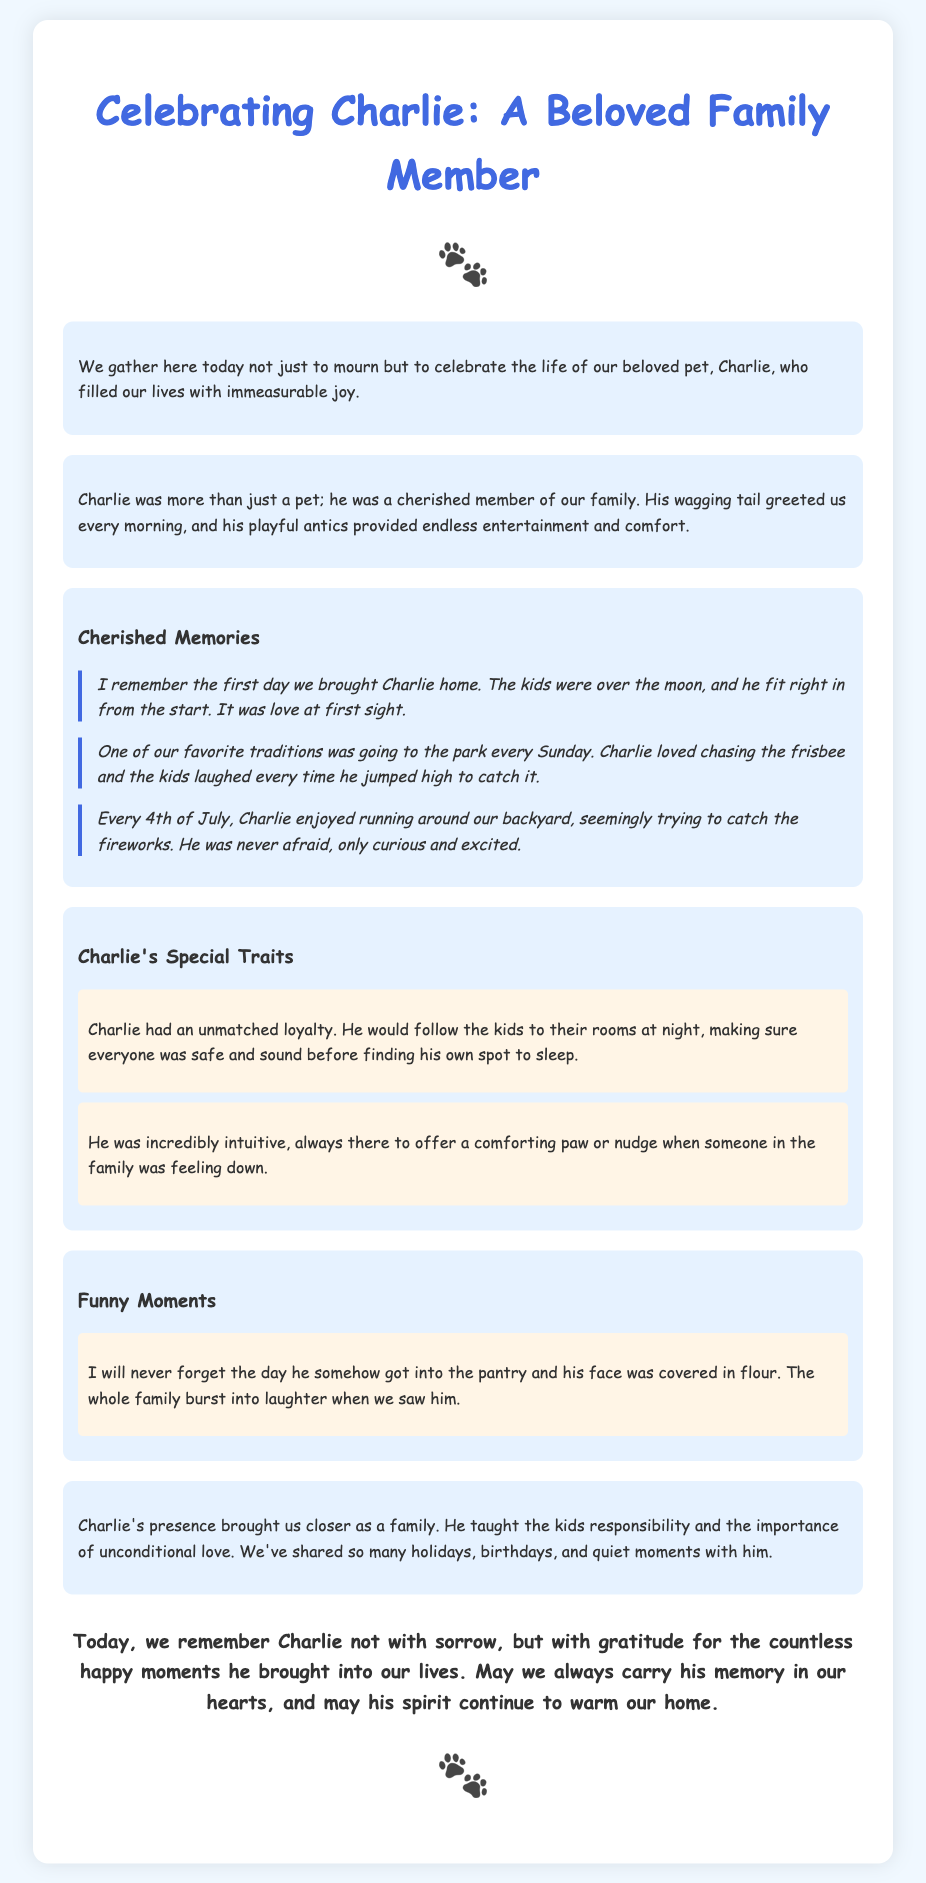What is the name of the pet being celebrated? The name of the pet mentioned in the eulogy is Charlie.
Answer: Charlie What was the family’s favorite tradition with Charlie? The favorite tradition was going to the park every Sunday, where Charlie loved to chase the frisbee.
Answer: Going to the park every Sunday What did Charlie do every 4th of July? Charlie enjoyed running around the backyard, seemingly trying to catch the fireworks.
Answer: Running around the backyard What was Charlie's unmatched trait? Charlie had unmatched loyalty, following the kids at night to ensure their safety.
Answer: Loyalty What was a funny moment shared in the eulogy? A funny moment mentioned was when Charlie got into the pantry and had flour on his face.
Answer: Face covered in flour How did Charlie's presence affect the family dynamics? Charlie’s presence brought the family closer, teaching responsibility and unconditional love.
Answer: Brought the family closer How did the family feel about Charlie at the end of the eulogy? The family felt gratitude for the countless happy moments Charlie brought into their lives.
Answer: Gratitude What is the overarching theme of the eulogy? The overarching theme is to celebrate Charlie's life and the joy he brought to the family.
Answer: Celebrate Charlie's life 